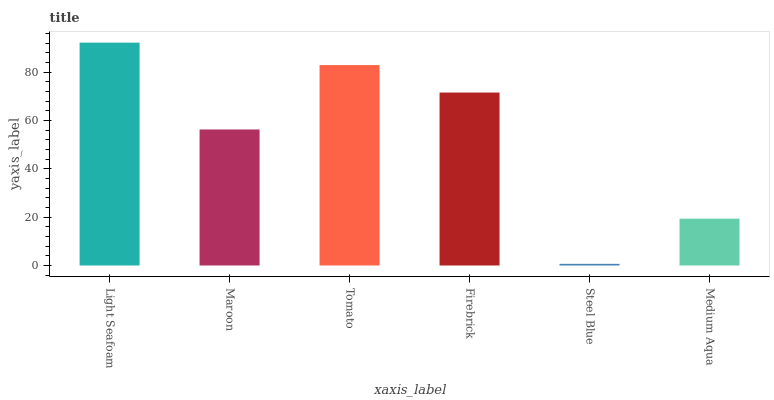Is Steel Blue the minimum?
Answer yes or no. Yes. Is Light Seafoam the maximum?
Answer yes or no. Yes. Is Maroon the minimum?
Answer yes or no. No. Is Maroon the maximum?
Answer yes or no. No. Is Light Seafoam greater than Maroon?
Answer yes or no. Yes. Is Maroon less than Light Seafoam?
Answer yes or no. Yes. Is Maroon greater than Light Seafoam?
Answer yes or no. No. Is Light Seafoam less than Maroon?
Answer yes or no. No. Is Firebrick the high median?
Answer yes or no. Yes. Is Maroon the low median?
Answer yes or no. Yes. Is Medium Aqua the high median?
Answer yes or no. No. Is Medium Aqua the low median?
Answer yes or no. No. 